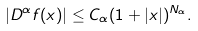Convert formula to latex. <formula><loc_0><loc_0><loc_500><loc_500>| D ^ { \alpha } f ( x ) | \leq C _ { \alpha } ( 1 + | x | ) ^ { N _ { \alpha } } .</formula> 